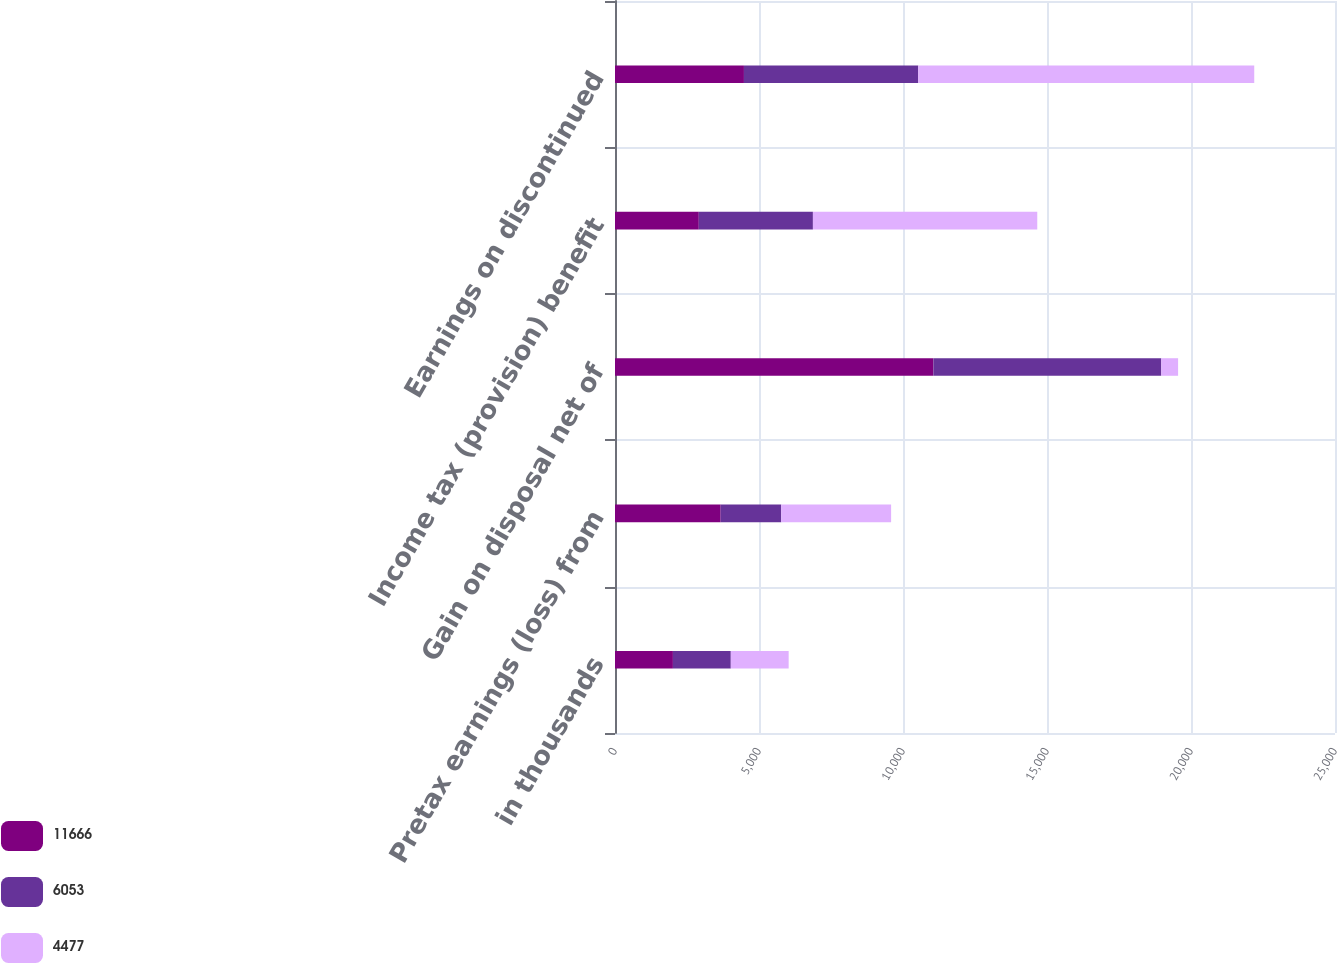Convert chart. <chart><loc_0><loc_0><loc_500><loc_500><stacked_bar_chart><ecel><fcel>in thousands<fcel>Pretax earnings (loss) from<fcel>Gain on disposal net of<fcel>Income tax (provision) benefit<fcel>Earnings on discontinued<nl><fcel>11666<fcel>2011<fcel>3669<fcel>11056<fcel>2910<fcel>4477<nl><fcel>6053<fcel>2010<fcel>2103<fcel>7912<fcel>3962<fcel>6053<nl><fcel>4477<fcel>2009<fcel>3815.5<fcel>584<fcel>7790<fcel>11666<nl></chart> 